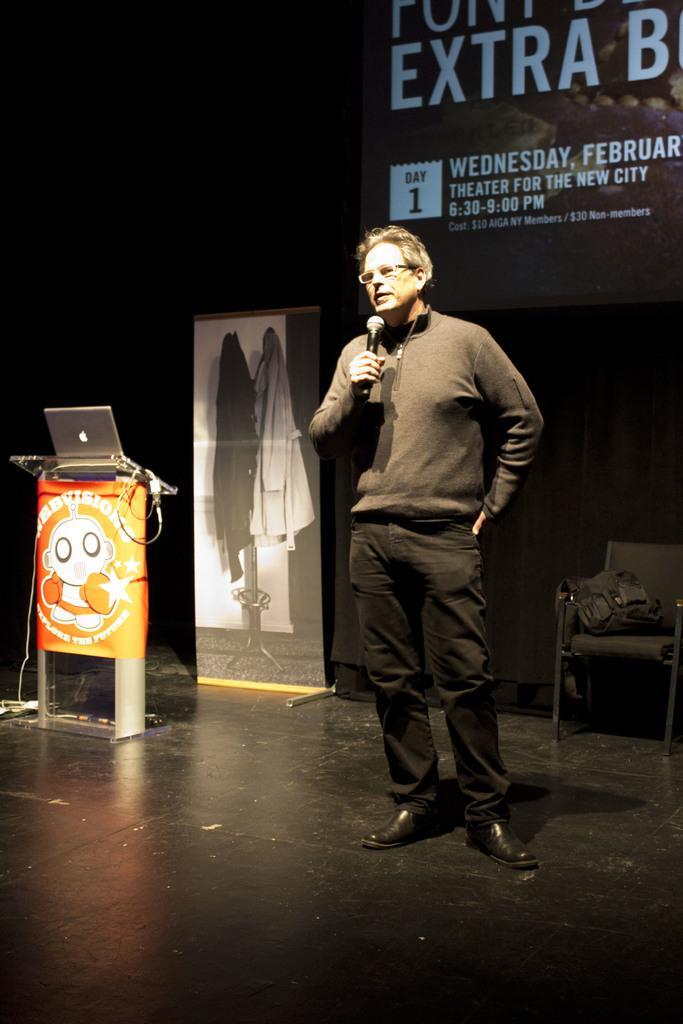How would you summarize this image in a sentence or two? In this image we can see a person standing on the stage holding a mic. On the left side we can see a laptop placed on the speaker stand. We can also see a board, curtain and some clothes on chair. 